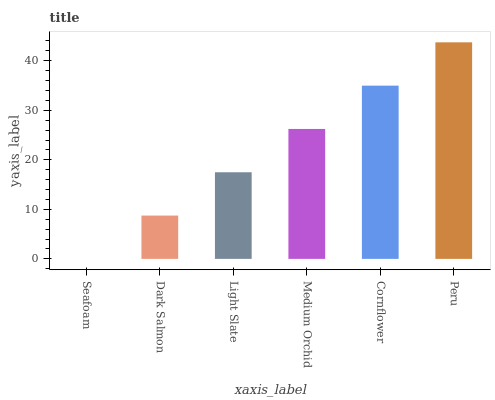Is Dark Salmon the minimum?
Answer yes or no. No. Is Dark Salmon the maximum?
Answer yes or no. No. Is Dark Salmon greater than Seafoam?
Answer yes or no. Yes. Is Seafoam less than Dark Salmon?
Answer yes or no. Yes. Is Seafoam greater than Dark Salmon?
Answer yes or no. No. Is Dark Salmon less than Seafoam?
Answer yes or no. No. Is Medium Orchid the high median?
Answer yes or no. Yes. Is Light Slate the low median?
Answer yes or no. Yes. Is Peru the high median?
Answer yes or no. No. Is Medium Orchid the low median?
Answer yes or no. No. 